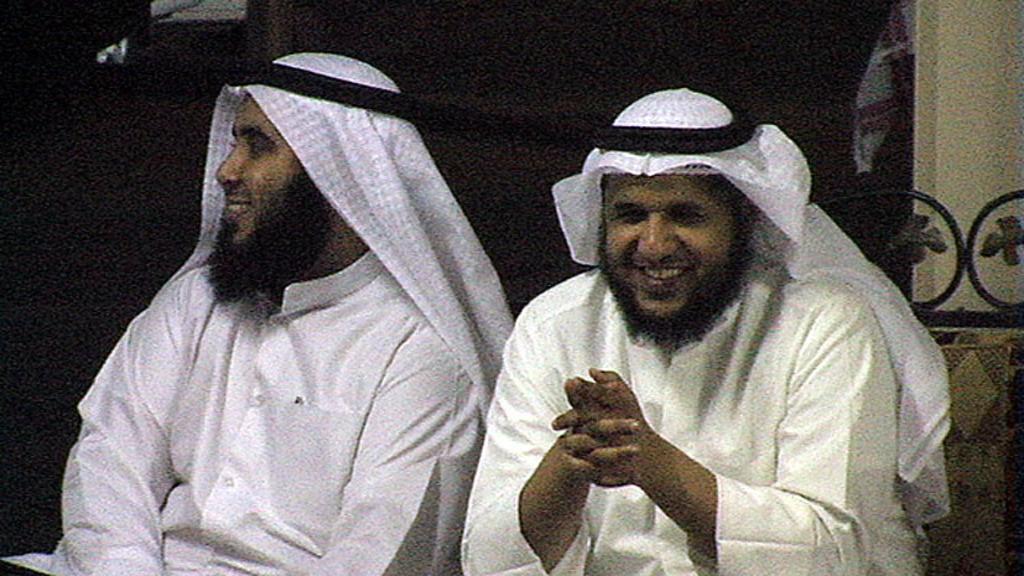Can you describe this image briefly? In this picture there are two men sitting on a couch, they are wearing white dresses. The background is not clear. 